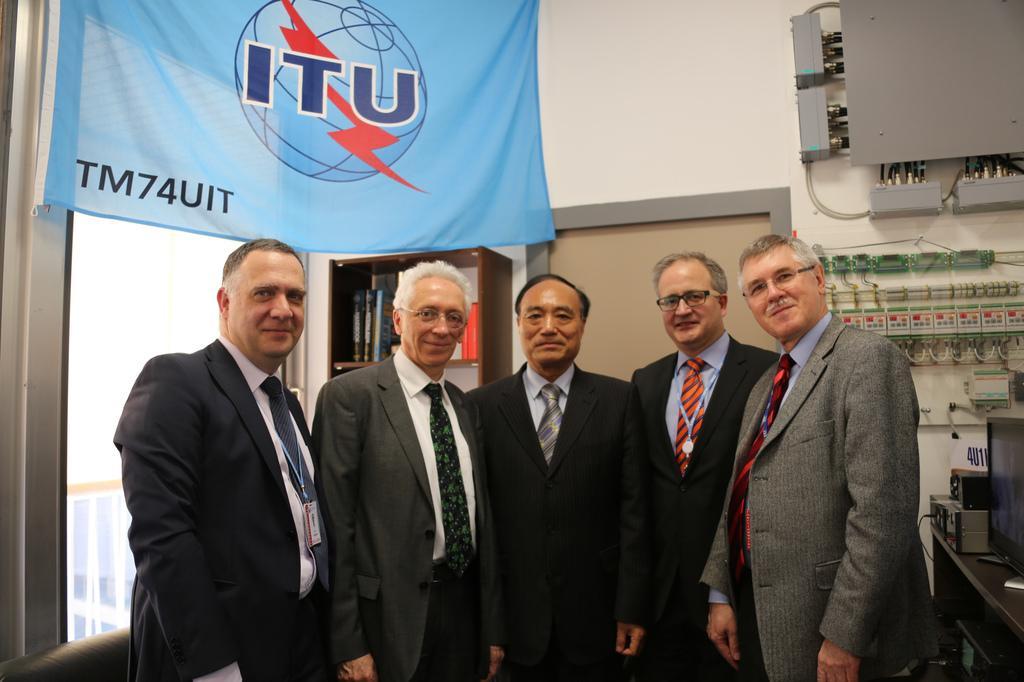In one or two sentences, can you explain what this image depicts? In the picture we can see a five men are standing and they are wearing a blazer, ties and shirts and in the background, we can see a wall with a door and some table with some things on it and on the ceiling we can see a banner which is blue in color with some symbol on it. 